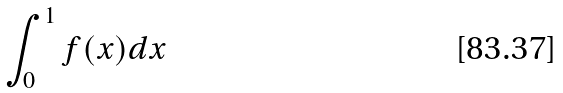<formula> <loc_0><loc_0><loc_500><loc_500>\int _ { 0 } ^ { 1 } f ( x ) d x</formula> 